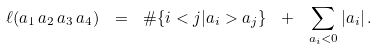Convert formula to latex. <formula><loc_0><loc_0><loc_500><loc_500>\ell ( a _ { 1 } \, a _ { 2 } \, a _ { 3 } \, a _ { 4 } ) \ = \ \# \{ i < j | a _ { i } > a _ { j } \} \ + \ \sum _ { a _ { i } < 0 } | a _ { i } | \, .</formula> 